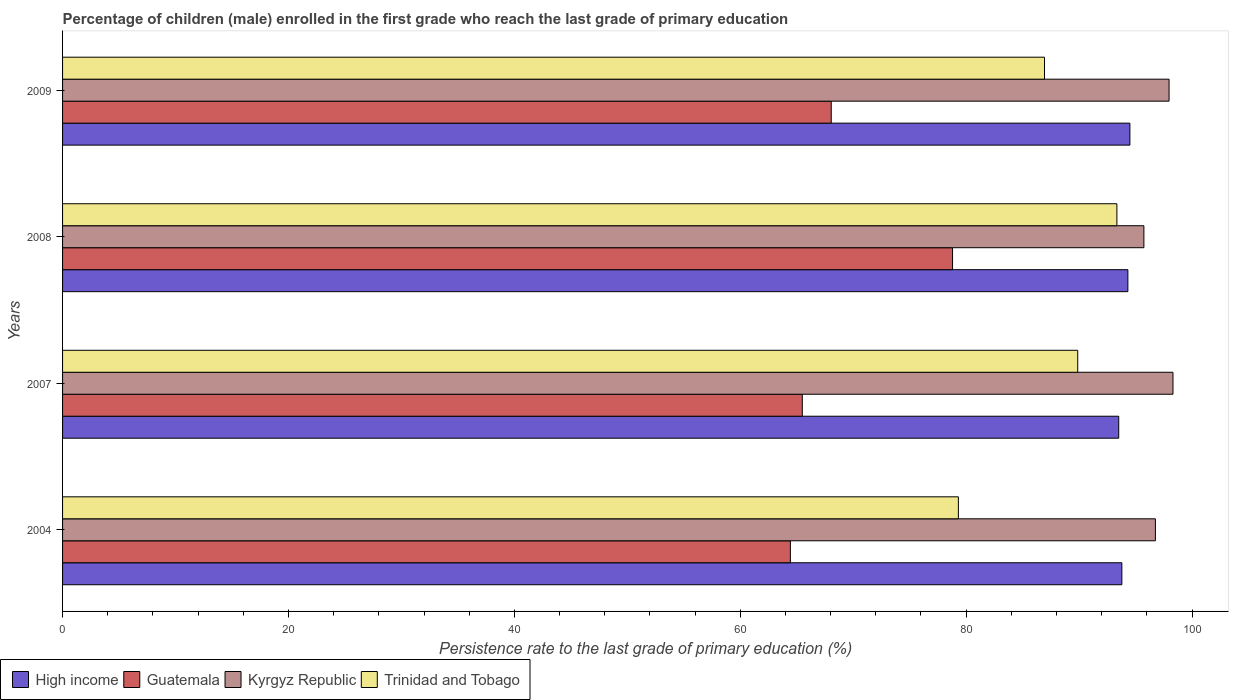How many different coloured bars are there?
Your answer should be compact. 4. How many groups of bars are there?
Your answer should be very brief. 4. Are the number of bars per tick equal to the number of legend labels?
Give a very brief answer. Yes. Are the number of bars on each tick of the Y-axis equal?
Keep it short and to the point. Yes. In how many cases, is the number of bars for a given year not equal to the number of legend labels?
Offer a very short reply. 0. What is the persistence rate of children in Trinidad and Tobago in 2007?
Your response must be concise. 89.88. Across all years, what is the maximum persistence rate of children in High income?
Offer a very short reply. 94.5. Across all years, what is the minimum persistence rate of children in High income?
Your answer should be compact. 93.51. In which year was the persistence rate of children in High income maximum?
Your answer should be compact. 2009. In which year was the persistence rate of children in High income minimum?
Ensure brevity in your answer.  2007. What is the total persistence rate of children in High income in the graph?
Your response must be concise. 376.11. What is the difference between the persistence rate of children in Guatemala in 2007 and that in 2009?
Your response must be concise. -2.56. What is the difference between the persistence rate of children in Kyrgyz Republic in 2004 and the persistence rate of children in High income in 2007?
Provide a short and direct response. 3.25. What is the average persistence rate of children in Kyrgyz Republic per year?
Ensure brevity in your answer.  97.19. In the year 2009, what is the difference between the persistence rate of children in Kyrgyz Republic and persistence rate of children in Trinidad and Tobago?
Ensure brevity in your answer.  11.03. In how many years, is the persistence rate of children in Trinidad and Tobago greater than 84 %?
Make the answer very short. 3. What is the ratio of the persistence rate of children in Kyrgyz Republic in 2004 to that in 2009?
Your answer should be very brief. 0.99. What is the difference between the highest and the second highest persistence rate of children in Trinidad and Tobago?
Your answer should be compact. 3.47. What is the difference between the highest and the lowest persistence rate of children in Trinidad and Tobago?
Your response must be concise. 14.03. In how many years, is the persistence rate of children in Kyrgyz Republic greater than the average persistence rate of children in Kyrgyz Republic taken over all years?
Your answer should be compact. 2. Is the sum of the persistence rate of children in Guatemala in 2004 and 2009 greater than the maximum persistence rate of children in High income across all years?
Offer a very short reply. Yes. What does the 4th bar from the top in 2007 represents?
Keep it short and to the point. High income. What does the 4th bar from the bottom in 2008 represents?
Provide a short and direct response. Trinidad and Tobago. Are all the bars in the graph horizontal?
Your answer should be very brief. Yes. Does the graph contain any zero values?
Provide a short and direct response. No. Does the graph contain grids?
Your answer should be very brief. No. Where does the legend appear in the graph?
Your answer should be compact. Bottom left. What is the title of the graph?
Your answer should be very brief. Percentage of children (male) enrolled in the first grade who reach the last grade of primary education. What is the label or title of the X-axis?
Provide a succinct answer. Persistence rate to the last grade of primary education (%). What is the label or title of the Y-axis?
Give a very brief answer. Years. What is the Persistence rate to the last grade of primary education (%) of High income in 2004?
Offer a terse response. 93.79. What is the Persistence rate to the last grade of primary education (%) of Guatemala in 2004?
Offer a terse response. 64.44. What is the Persistence rate to the last grade of primary education (%) of Kyrgyz Republic in 2004?
Provide a short and direct response. 96.75. What is the Persistence rate to the last grade of primary education (%) of Trinidad and Tobago in 2004?
Make the answer very short. 79.31. What is the Persistence rate to the last grade of primary education (%) in High income in 2007?
Give a very brief answer. 93.51. What is the Persistence rate to the last grade of primary education (%) in Guatemala in 2007?
Ensure brevity in your answer.  65.49. What is the Persistence rate to the last grade of primary education (%) in Kyrgyz Republic in 2007?
Ensure brevity in your answer.  98.31. What is the Persistence rate to the last grade of primary education (%) of Trinidad and Tobago in 2007?
Provide a short and direct response. 89.88. What is the Persistence rate to the last grade of primary education (%) of High income in 2008?
Make the answer very short. 94.32. What is the Persistence rate to the last grade of primary education (%) of Guatemala in 2008?
Provide a succinct answer. 78.79. What is the Persistence rate to the last grade of primary education (%) in Kyrgyz Republic in 2008?
Offer a terse response. 95.74. What is the Persistence rate to the last grade of primary education (%) of Trinidad and Tobago in 2008?
Offer a terse response. 93.35. What is the Persistence rate to the last grade of primary education (%) in High income in 2009?
Make the answer very short. 94.5. What is the Persistence rate to the last grade of primary education (%) in Guatemala in 2009?
Make the answer very short. 68.05. What is the Persistence rate to the last grade of primary education (%) of Kyrgyz Republic in 2009?
Ensure brevity in your answer.  97.96. What is the Persistence rate to the last grade of primary education (%) in Trinidad and Tobago in 2009?
Your response must be concise. 86.94. Across all years, what is the maximum Persistence rate to the last grade of primary education (%) of High income?
Offer a terse response. 94.5. Across all years, what is the maximum Persistence rate to the last grade of primary education (%) of Guatemala?
Offer a very short reply. 78.79. Across all years, what is the maximum Persistence rate to the last grade of primary education (%) of Kyrgyz Republic?
Your response must be concise. 98.31. Across all years, what is the maximum Persistence rate to the last grade of primary education (%) of Trinidad and Tobago?
Keep it short and to the point. 93.35. Across all years, what is the minimum Persistence rate to the last grade of primary education (%) of High income?
Provide a short and direct response. 93.51. Across all years, what is the minimum Persistence rate to the last grade of primary education (%) in Guatemala?
Provide a short and direct response. 64.44. Across all years, what is the minimum Persistence rate to the last grade of primary education (%) in Kyrgyz Republic?
Your answer should be compact. 95.74. Across all years, what is the minimum Persistence rate to the last grade of primary education (%) of Trinidad and Tobago?
Offer a terse response. 79.31. What is the total Persistence rate to the last grade of primary education (%) in High income in the graph?
Your response must be concise. 376.11. What is the total Persistence rate to the last grade of primary education (%) of Guatemala in the graph?
Make the answer very short. 276.78. What is the total Persistence rate to the last grade of primary education (%) of Kyrgyz Republic in the graph?
Offer a very short reply. 388.76. What is the total Persistence rate to the last grade of primary education (%) in Trinidad and Tobago in the graph?
Offer a terse response. 349.47. What is the difference between the Persistence rate to the last grade of primary education (%) of High income in 2004 and that in 2007?
Offer a very short reply. 0.28. What is the difference between the Persistence rate to the last grade of primary education (%) of Guatemala in 2004 and that in 2007?
Your answer should be very brief. -1.05. What is the difference between the Persistence rate to the last grade of primary education (%) in Kyrgyz Republic in 2004 and that in 2007?
Offer a terse response. -1.56. What is the difference between the Persistence rate to the last grade of primary education (%) in Trinidad and Tobago in 2004 and that in 2007?
Your answer should be compact. -10.57. What is the difference between the Persistence rate to the last grade of primary education (%) in High income in 2004 and that in 2008?
Offer a very short reply. -0.53. What is the difference between the Persistence rate to the last grade of primary education (%) in Guatemala in 2004 and that in 2008?
Keep it short and to the point. -14.36. What is the difference between the Persistence rate to the last grade of primary education (%) in Kyrgyz Republic in 2004 and that in 2008?
Make the answer very short. 1.02. What is the difference between the Persistence rate to the last grade of primary education (%) of Trinidad and Tobago in 2004 and that in 2008?
Ensure brevity in your answer.  -14.04. What is the difference between the Persistence rate to the last grade of primary education (%) in High income in 2004 and that in 2009?
Give a very brief answer. -0.71. What is the difference between the Persistence rate to the last grade of primary education (%) in Guatemala in 2004 and that in 2009?
Make the answer very short. -3.62. What is the difference between the Persistence rate to the last grade of primary education (%) of Kyrgyz Republic in 2004 and that in 2009?
Provide a short and direct response. -1.21. What is the difference between the Persistence rate to the last grade of primary education (%) of Trinidad and Tobago in 2004 and that in 2009?
Your answer should be very brief. -7.62. What is the difference between the Persistence rate to the last grade of primary education (%) in High income in 2007 and that in 2008?
Give a very brief answer. -0.81. What is the difference between the Persistence rate to the last grade of primary education (%) in Guatemala in 2007 and that in 2008?
Your answer should be very brief. -13.3. What is the difference between the Persistence rate to the last grade of primary education (%) in Kyrgyz Republic in 2007 and that in 2008?
Provide a succinct answer. 2.58. What is the difference between the Persistence rate to the last grade of primary education (%) of Trinidad and Tobago in 2007 and that in 2008?
Ensure brevity in your answer.  -3.47. What is the difference between the Persistence rate to the last grade of primary education (%) in High income in 2007 and that in 2009?
Offer a terse response. -0.99. What is the difference between the Persistence rate to the last grade of primary education (%) of Guatemala in 2007 and that in 2009?
Keep it short and to the point. -2.56. What is the difference between the Persistence rate to the last grade of primary education (%) in Kyrgyz Republic in 2007 and that in 2009?
Give a very brief answer. 0.35. What is the difference between the Persistence rate to the last grade of primary education (%) of Trinidad and Tobago in 2007 and that in 2009?
Make the answer very short. 2.94. What is the difference between the Persistence rate to the last grade of primary education (%) of High income in 2008 and that in 2009?
Your answer should be compact. -0.18. What is the difference between the Persistence rate to the last grade of primary education (%) of Guatemala in 2008 and that in 2009?
Offer a very short reply. 10.74. What is the difference between the Persistence rate to the last grade of primary education (%) in Kyrgyz Republic in 2008 and that in 2009?
Keep it short and to the point. -2.23. What is the difference between the Persistence rate to the last grade of primary education (%) in Trinidad and Tobago in 2008 and that in 2009?
Ensure brevity in your answer.  6.41. What is the difference between the Persistence rate to the last grade of primary education (%) in High income in 2004 and the Persistence rate to the last grade of primary education (%) in Guatemala in 2007?
Offer a very short reply. 28.29. What is the difference between the Persistence rate to the last grade of primary education (%) in High income in 2004 and the Persistence rate to the last grade of primary education (%) in Kyrgyz Republic in 2007?
Your response must be concise. -4.53. What is the difference between the Persistence rate to the last grade of primary education (%) of High income in 2004 and the Persistence rate to the last grade of primary education (%) of Trinidad and Tobago in 2007?
Your response must be concise. 3.91. What is the difference between the Persistence rate to the last grade of primary education (%) in Guatemala in 2004 and the Persistence rate to the last grade of primary education (%) in Kyrgyz Republic in 2007?
Give a very brief answer. -33.87. What is the difference between the Persistence rate to the last grade of primary education (%) of Guatemala in 2004 and the Persistence rate to the last grade of primary education (%) of Trinidad and Tobago in 2007?
Your answer should be very brief. -25.44. What is the difference between the Persistence rate to the last grade of primary education (%) in Kyrgyz Republic in 2004 and the Persistence rate to the last grade of primary education (%) in Trinidad and Tobago in 2007?
Keep it short and to the point. 6.88. What is the difference between the Persistence rate to the last grade of primary education (%) of High income in 2004 and the Persistence rate to the last grade of primary education (%) of Guatemala in 2008?
Give a very brief answer. 14.99. What is the difference between the Persistence rate to the last grade of primary education (%) of High income in 2004 and the Persistence rate to the last grade of primary education (%) of Kyrgyz Republic in 2008?
Your answer should be compact. -1.95. What is the difference between the Persistence rate to the last grade of primary education (%) of High income in 2004 and the Persistence rate to the last grade of primary education (%) of Trinidad and Tobago in 2008?
Your answer should be very brief. 0.44. What is the difference between the Persistence rate to the last grade of primary education (%) of Guatemala in 2004 and the Persistence rate to the last grade of primary education (%) of Kyrgyz Republic in 2008?
Give a very brief answer. -31.3. What is the difference between the Persistence rate to the last grade of primary education (%) in Guatemala in 2004 and the Persistence rate to the last grade of primary education (%) in Trinidad and Tobago in 2008?
Keep it short and to the point. -28.91. What is the difference between the Persistence rate to the last grade of primary education (%) in Kyrgyz Republic in 2004 and the Persistence rate to the last grade of primary education (%) in Trinidad and Tobago in 2008?
Offer a terse response. 3.41. What is the difference between the Persistence rate to the last grade of primary education (%) of High income in 2004 and the Persistence rate to the last grade of primary education (%) of Guatemala in 2009?
Give a very brief answer. 25.73. What is the difference between the Persistence rate to the last grade of primary education (%) in High income in 2004 and the Persistence rate to the last grade of primary education (%) in Kyrgyz Republic in 2009?
Make the answer very short. -4.18. What is the difference between the Persistence rate to the last grade of primary education (%) of High income in 2004 and the Persistence rate to the last grade of primary education (%) of Trinidad and Tobago in 2009?
Your response must be concise. 6.85. What is the difference between the Persistence rate to the last grade of primary education (%) in Guatemala in 2004 and the Persistence rate to the last grade of primary education (%) in Kyrgyz Republic in 2009?
Your response must be concise. -33.53. What is the difference between the Persistence rate to the last grade of primary education (%) of Guatemala in 2004 and the Persistence rate to the last grade of primary education (%) of Trinidad and Tobago in 2009?
Provide a succinct answer. -22.5. What is the difference between the Persistence rate to the last grade of primary education (%) in Kyrgyz Republic in 2004 and the Persistence rate to the last grade of primary education (%) in Trinidad and Tobago in 2009?
Make the answer very short. 9.82. What is the difference between the Persistence rate to the last grade of primary education (%) in High income in 2007 and the Persistence rate to the last grade of primary education (%) in Guatemala in 2008?
Provide a short and direct response. 14.71. What is the difference between the Persistence rate to the last grade of primary education (%) in High income in 2007 and the Persistence rate to the last grade of primary education (%) in Kyrgyz Republic in 2008?
Your response must be concise. -2.23. What is the difference between the Persistence rate to the last grade of primary education (%) of High income in 2007 and the Persistence rate to the last grade of primary education (%) of Trinidad and Tobago in 2008?
Your response must be concise. 0.16. What is the difference between the Persistence rate to the last grade of primary education (%) of Guatemala in 2007 and the Persistence rate to the last grade of primary education (%) of Kyrgyz Republic in 2008?
Give a very brief answer. -30.24. What is the difference between the Persistence rate to the last grade of primary education (%) of Guatemala in 2007 and the Persistence rate to the last grade of primary education (%) of Trinidad and Tobago in 2008?
Your answer should be compact. -27.85. What is the difference between the Persistence rate to the last grade of primary education (%) in Kyrgyz Republic in 2007 and the Persistence rate to the last grade of primary education (%) in Trinidad and Tobago in 2008?
Your answer should be compact. 4.96. What is the difference between the Persistence rate to the last grade of primary education (%) in High income in 2007 and the Persistence rate to the last grade of primary education (%) in Guatemala in 2009?
Give a very brief answer. 25.45. What is the difference between the Persistence rate to the last grade of primary education (%) of High income in 2007 and the Persistence rate to the last grade of primary education (%) of Kyrgyz Republic in 2009?
Your answer should be very brief. -4.46. What is the difference between the Persistence rate to the last grade of primary education (%) in High income in 2007 and the Persistence rate to the last grade of primary education (%) in Trinidad and Tobago in 2009?
Your answer should be very brief. 6.57. What is the difference between the Persistence rate to the last grade of primary education (%) in Guatemala in 2007 and the Persistence rate to the last grade of primary education (%) in Kyrgyz Republic in 2009?
Your response must be concise. -32.47. What is the difference between the Persistence rate to the last grade of primary education (%) in Guatemala in 2007 and the Persistence rate to the last grade of primary education (%) in Trinidad and Tobago in 2009?
Your answer should be very brief. -21.44. What is the difference between the Persistence rate to the last grade of primary education (%) of Kyrgyz Republic in 2007 and the Persistence rate to the last grade of primary education (%) of Trinidad and Tobago in 2009?
Make the answer very short. 11.37. What is the difference between the Persistence rate to the last grade of primary education (%) of High income in 2008 and the Persistence rate to the last grade of primary education (%) of Guatemala in 2009?
Your response must be concise. 26.26. What is the difference between the Persistence rate to the last grade of primary education (%) in High income in 2008 and the Persistence rate to the last grade of primary education (%) in Kyrgyz Republic in 2009?
Your response must be concise. -3.65. What is the difference between the Persistence rate to the last grade of primary education (%) in High income in 2008 and the Persistence rate to the last grade of primary education (%) in Trinidad and Tobago in 2009?
Provide a succinct answer. 7.38. What is the difference between the Persistence rate to the last grade of primary education (%) in Guatemala in 2008 and the Persistence rate to the last grade of primary education (%) in Kyrgyz Republic in 2009?
Ensure brevity in your answer.  -19.17. What is the difference between the Persistence rate to the last grade of primary education (%) in Guatemala in 2008 and the Persistence rate to the last grade of primary education (%) in Trinidad and Tobago in 2009?
Make the answer very short. -8.14. What is the difference between the Persistence rate to the last grade of primary education (%) of Kyrgyz Republic in 2008 and the Persistence rate to the last grade of primary education (%) of Trinidad and Tobago in 2009?
Make the answer very short. 8.8. What is the average Persistence rate to the last grade of primary education (%) of High income per year?
Provide a short and direct response. 94.03. What is the average Persistence rate to the last grade of primary education (%) of Guatemala per year?
Your answer should be compact. 69.19. What is the average Persistence rate to the last grade of primary education (%) in Kyrgyz Republic per year?
Your answer should be compact. 97.19. What is the average Persistence rate to the last grade of primary education (%) of Trinidad and Tobago per year?
Give a very brief answer. 87.37. In the year 2004, what is the difference between the Persistence rate to the last grade of primary education (%) of High income and Persistence rate to the last grade of primary education (%) of Guatemala?
Ensure brevity in your answer.  29.35. In the year 2004, what is the difference between the Persistence rate to the last grade of primary education (%) in High income and Persistence rate to the last grade of primary education (%) in Kyrgyz Republic?
Your answer should be very brief. -2.97. In the year 2004, what is the difference between the Persistence rate to the last grade of primary education (%) in High income and Persistence rate to the last grade of primary education (%) in Trinidad and Tobago?
Your answer should be compact. 14.47. In the year 2004, what is the difference between the Persistence rate to the last grade of primary education (%) of Guatemala and Persistence rate to the last grade of primary education (%) of Kyrgyz Republic?
Your answer should be very brief. -32.32. In the year 2004, what is the difference between the Persistence rate to the last grade of primary education (%) of Guatemala and Persistence rate to the last grade of primary education (%) of Trinidad and Tobago?
Provide a short and direct response. -14.87. In the year 2004, what is the difference between the Persistence rate to the last grade of primary education (%) in Kyrgyz Republic and Persistence rate to the last grade of primary education (%) in Trinidad and Tobago?
Offer a very short reply. 17.44. In the year 2007, what is the difference between the Persistence rate to the last grade of primary education (%) in High income and Persistence rate to the last grade of primary education (%) in Guatemala?
Your response must be concise. 28.02. In the year 2007, what is the difference between the Persistence rate to the last grade of primary education (%) in High income and Persistence rate to the last grade of primary education (%) in Kyrgyz Republic?
Provide a succinct answer. -4.8. In the year 2007, what is the difference between the Persistence rate to the last grade of primary education (%) of High income and Persistence rate to the last grade of primary education (%) of Trinidad and Tobago?
Make the answer very short. 3.63. In the year 2007, what is the difference between the Persistence rate to the last grade of primary education (%) in Guatemala and Persistence rate to the last grade of primary education (%) in Kyrgyz Republic?
Provide a short and direct response. -32.82. In the year 2007, what is the difference between the Persistence rate to the last grade of primary education (%) in Guatemala and Persistence rate to the last grade of primary education (%) in Trinidad and Tobago?
Your answer should be very brief. -24.38. In the year 2007, what is the difference between the Persistence rate to the last grade of primary education (%) in Kyrgyz Republic and Persistence rate to the last grade of primary education (%) in Trinidad and Tobago?
Keep it short and to the point. 8.43. In the year 2008, what is the difference between the Persistence rate to the last grade of primary education (%) in High income and Persistence rate to the last grade of primary education (%) in Guatemala?
Your answer should be compact. 15.52. In the year 2008, what is the difference between the Persistence rate to the last grade of primary education (%) of High income and Persistence rate to the last grade of primary education (%) of Kyrgyz Republic?
Make the answer very short. -1.42. In the year 2008, what is the difference between the Persistence rate to the last grade of primary education (%) in High income and Persistence rate to the last grade of primary education (%) in Trinidad and Tobago?
Ensure brevity in your answer.  0.97. In the year 2008, what is the difference between the Persistence rate to the last grade of primary education (%) in Guatemala and Persistence rate to the last grade of primary education (%) in Kyrgyz Republic?
Your response must be concise. -16.94. In the year 2008, what is the difference between the Persistence rate to the last grade of primary education (%) of Guatemala and Persistence rate to the last grade of primary education (%) of Trinidad and Tobago?
Your response must be concise. -14.55. In the year 2008, what is the difference between the Persistence rate to the last grade of primary education (%) of Kyrgyz Republic and Persistence rate to the last grade of primary education (%) of Trinidad and Tobago?
Offer a terse response. 2.39. In the year 2009, what is the difference between the Persistence rate to the last grade of primary education (%) of High income and Persistence rate to the last grade of primary education (%) of Guatemala?
Give a very brief answer. 26.44. In the year 2009, what is the difference between the Persistence rate to the last grade of primary education (%) of High income and Persistence rate to the last grade of primary education (%) of Kyrgyz Republic?
Your response must be concise. -3.47. In the year 2009, what is the difference between the Persistence rate to the last grade of primary education (%) in High income and Persistence rate to the last grade of primary education (%) in Trinidad and Tobago?
Provide a succinct answer. 7.56. In the year 2009, what is the difference between the Persistence rate to the last grade of primary education (%) in Guatemala and Persistence rate to the last grade of primary education (%) in Kyrgyz Republic?
Your response must be concise. -29.91. In the year 2009, what is the difference between the Persistence rate to the last grade of primary education (%) of Guatemala and Persistence rate to the last grade of primary education (%) of Trinidad and Tobago?
Provide a short and direct response. -18.88. In the year 2009, what is the difference between the Persistence rate to the last grade of primary education (%) of Kyrgyz Republic and Persistence rate to the last grade of primary education (%) of Trinidad and Tobago?
Your answer should be compact. 11.03. What is the ratio of the Persistence rate to the last grade of primary education (%) of Guatemala in 2004 to that in 2007?
Give a very brief answer. 0.98. What is the ratio of the Persistence rate to the last grade of primary education (%) in Kyrgyz Republic in 2004 to that in 2007?
Offer a terse response. 0.98. What is the ratio of the Persistence rate to the last grade of primary education (%) in Trinidad and Tobago in 2004 to that in 2007?
Give a very brief answer. 0.88. What is the ratio of the Persistence rate to the last grade of primary education (%) of High income in 2004 to that in 2008?
Make the answer very short. 0.99. What is the ratio of the Persistence rate to the last grade of primary education (%) of Guatemala in 2004 to that in 2008?
Your answer should be very brief. 0.82. What is the ratio of the Persistence rate to the last grade of primary education (%) in Kyrgyz Republic in 2004 to that in 2008?
Keep it short and to the point. 1.01. What is the ratio of the Persistence rate to the last grade of primary education (%) in Trinidad and Tobago in 2004 to that in 2008?
Offer a very short reply. 0.85. What is the ratio of the Persistence rate to the last grade of primary education (%) in Guatemala in 2004 to that in 2009?
Keep it short and to the point. 0.95. What is the ratio of the Persistence rate to the last grade of primary education (%) of Kyrgyz Republic in 2004 to that in 2009?
Your answer should be compact. 0.99. What is the ratio of the Persistence rate to the last grade of primary education (%) of Trinidad and Tobago in 2004 to that in 2009?
Your response must be concise. 0.91. What is the ratio of the Persistence rate to the last grade of primary education (%) in High income in 2007 to that in 2008?
Your answer should be compact. 0.99. What is the ratio of the Persistence rate to the last grade of primary education (%) of Guatemala in 2007 to that in 2008?
Offer a terse response. 0.83. What is the ratio of the Persistence rate to the last grade of primary education (%) of Kyrgyz Republic in 2007 to that in 2008?
Offer a terse response. 1.03. What is the ratio of the Persistence rate to the last grade of primary education (%) of Trinidad and Tobago in 2007 to that in 2008?
Your answer should be very brief. 0.96. What is the ratio of the Persistence rate to the last grade of primary education (%) in High income in 2007 to that in 2009?
Your answer should be very brief. 0.99. What is the ratio of the Persistence rate to the last grade of primary education (%) in Guatemala in 2007 to that in 2009?
Provide a short and direct response. 0.96. What is the ratio of the Persistence rate to the last grade of primary education (%) in Trinidad and Tobago in 2007 to that in 2009?
Your answer should be very brief. 1.03. What is the ratio of the Persistence rate to the last grade of primary education (%) in High income in 2008 to that in 2009?
Give a very brief answer. 1. What is the ratio of the Persistence rate to the last grade of primary education (%) of Guatemala in 2008 to that in 2009?
Your answer should be very brief. 1.16. What is the ratio of the Persistence rate to the last grade of primary education (%) in Kyrgyz Republic in 2008 to that in 2009?
Your answer should be compact. 0.98. What is the ratio of the Persistence rate to the last grade of primary education (%) in Trinidad and Tobago in 2008 to that in 2009?
Give a very brief answer. 1.07. What is the difference between the highest and the second highest Persistence rate to the last grade of primary education (%) in High income?
Your answer should be very brief. 0.18. What is the difference between the highest and the second highest Persistence rate to the last grade of primary education (%) in Guatemala?
Give a very brief answer. 10.74. What is the difference between the highest and the second highest Persistence rate to the last grade of primary education (%) of Kyrgyz Republic?
Provide a short and direct response. 0.35. What is the difference between the highest and the second highest Persistence rate to the last grade of primary education (%) of Trinidad and Tobago?
Your answer should be very brief. 3.47. What is the difference between the highest and the lowest Persistence rate to the last grade of primary education (%) of Guatemala?
Your answer should be compact. 14.36. What is the difference between the highest and the lowest Persistence rate to the last grade of primary education (%) in Kyrgyz Republic?
Your response must be concise. 2.58. What is the difference between the highest and the lowest Persistence rate to the last grade of primary education (%) of Trinidad and Tobago?
Your response must be concise. 14.04. 